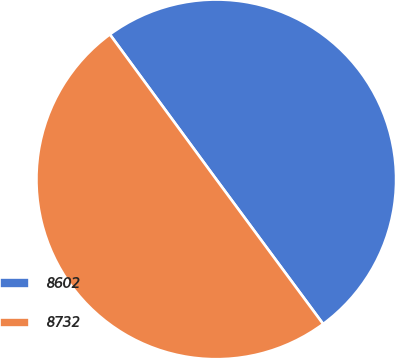Convert chart to OTSL. <chart><loc_0><loc_0><loc_500><loc_500><pie_chart><fcel>8602<fcel>8732<nl><fcel>49.95%<fcel>50.05%<nl></chart> 